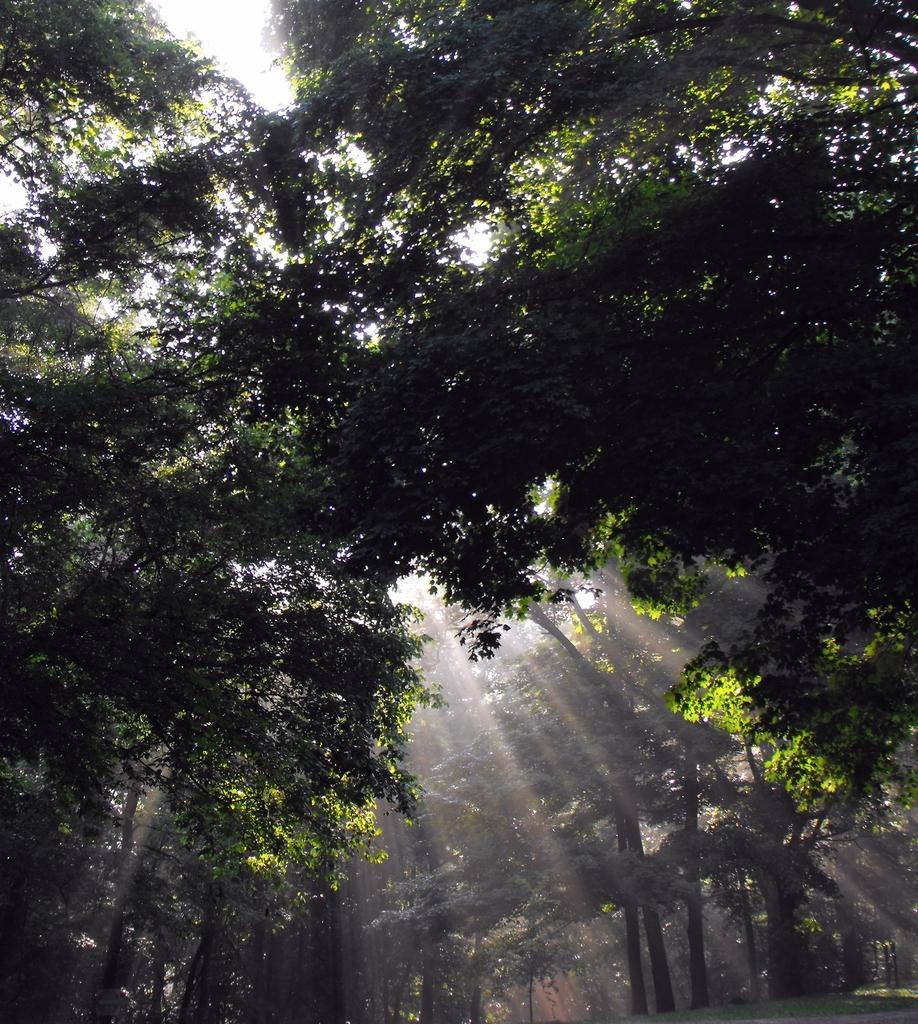Could you give a brief overview of what you see in this image? In this image we can see trees, grass and sky. 